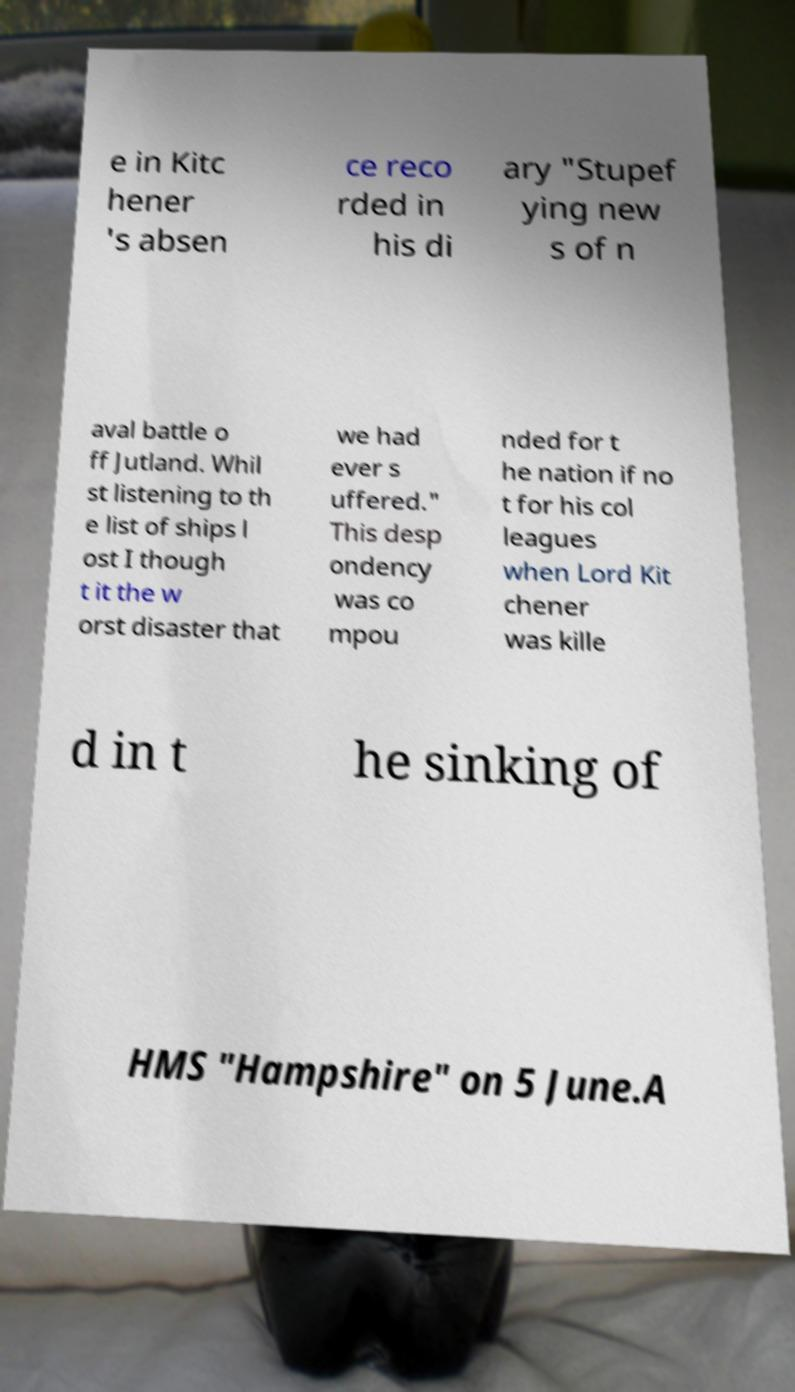What messages or text are displayed in this image? I need them in a readable, typed format. e in Kitc hener 's absen ce reco rded in his di ary "Stupef ying new s of n aval battle o ff Jutland. Whil st listening to th e list of ships l ost I though t it the w orst disaster that we had ever s uffered." This desp ondency was co mpou nded for t he nation if no t for his col leagues when Lord Kit chener was kille d in t he sinking of HMS "Hampshire" on 5 June.A 